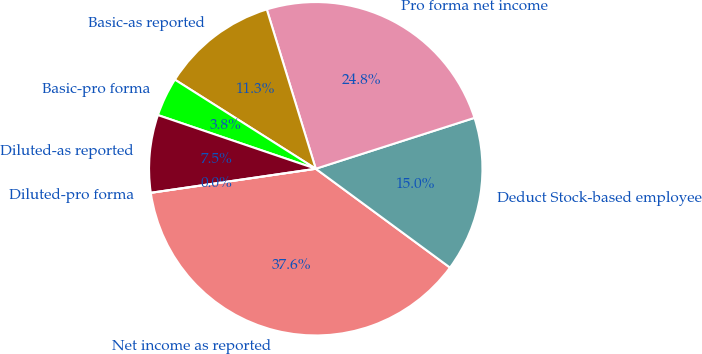<chart> <loc_0><loc_0><loc_500><loc_500><pie_chart><fcel>Net income as reported<fcel>Deduct Stock-based employee<fcel>Pro forma net income<fcel>Basic-as reported<fcel>Basic-pro forma<fcel>Diluted-as reported<fcel>Diluted-pro forma<nl><fcel>37.6%<fcel>15.04%<fcel>24.81%<fcel>11.28%<fcel>3.76%<fcel>7.52%<fcel>0.0%<nl></chart> 